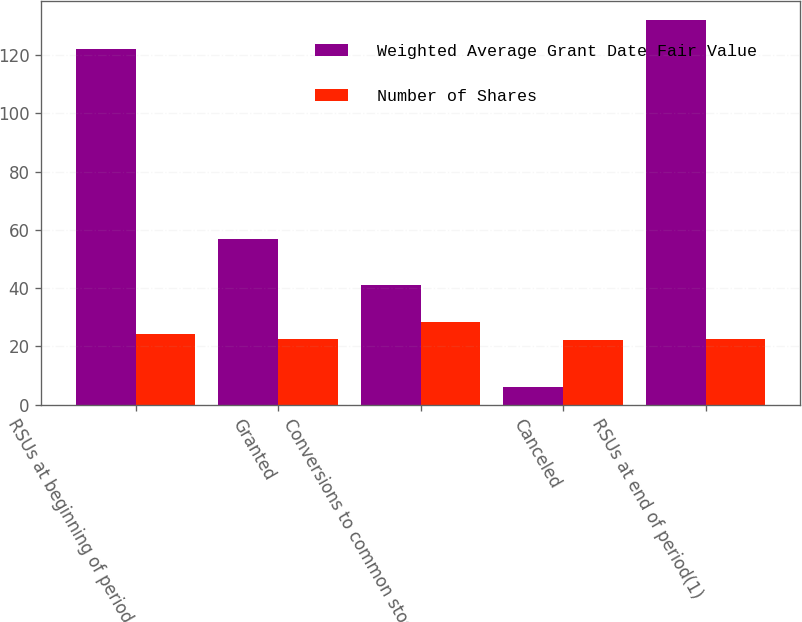Convert chart. <chart><loc_0><loc_0><loc_500><loc_500><stacked_bar_chart><ecel><fcel>RSUs at beginning of period<fcel>Granted<fcel>Conversions to common stock<fcel>Canceled<fcel>RSUs at end of period(1)<nl><fcel>Weighted Average Grant Date Fair Value<fcel>122<fcel>57<fcel>41<fcel>6<fcel>132<nl><fcel>Number of Shares<fcel>24.29<fcel>22.72<fcel>28.51<fcel>22.21<fcel>22.41<nl></chart> 